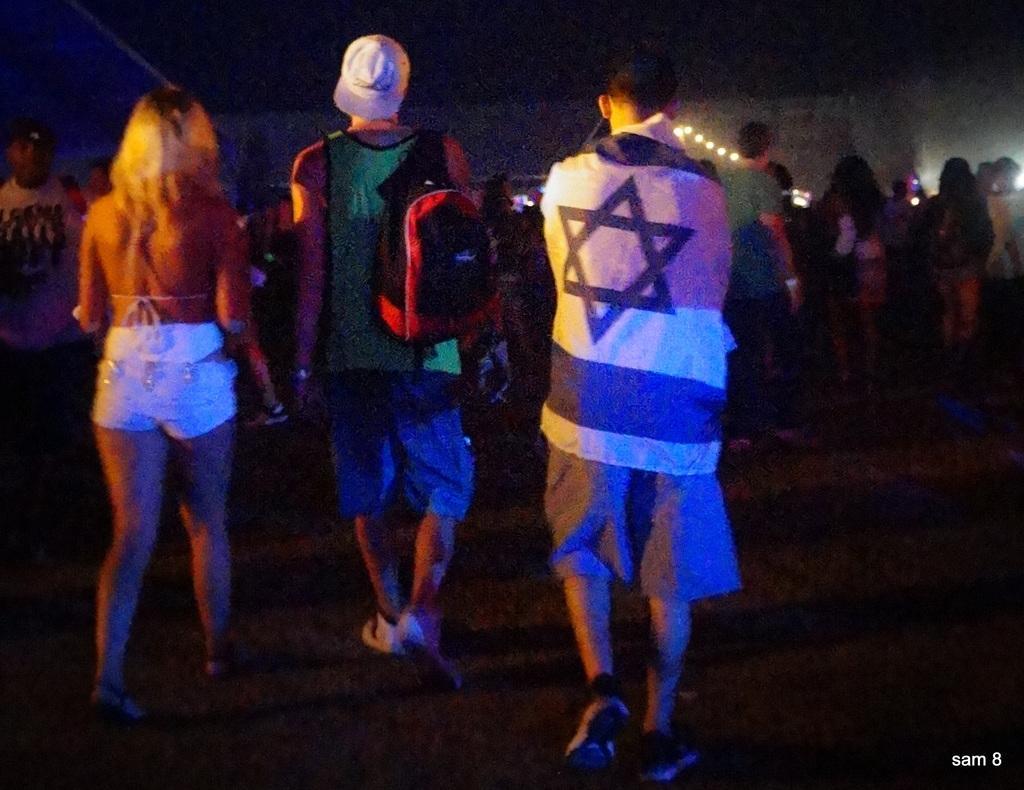In one or two sentences, can you explain what this image depicts? In this image, we can see people and some are wearing bags and some are wearing caps. At the bottom, there is ground and we can see some text. At the top, there are lights. 